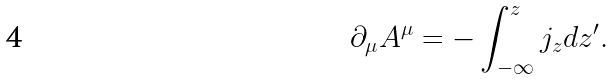<formula> <loc_0><loc_0><loc_500><loc_500>\partial _ { \mu } A ^ { \mu } = - \int ^ { z } _ { - \infty } j _ { z } d z ^ { \prime } .</formula> 